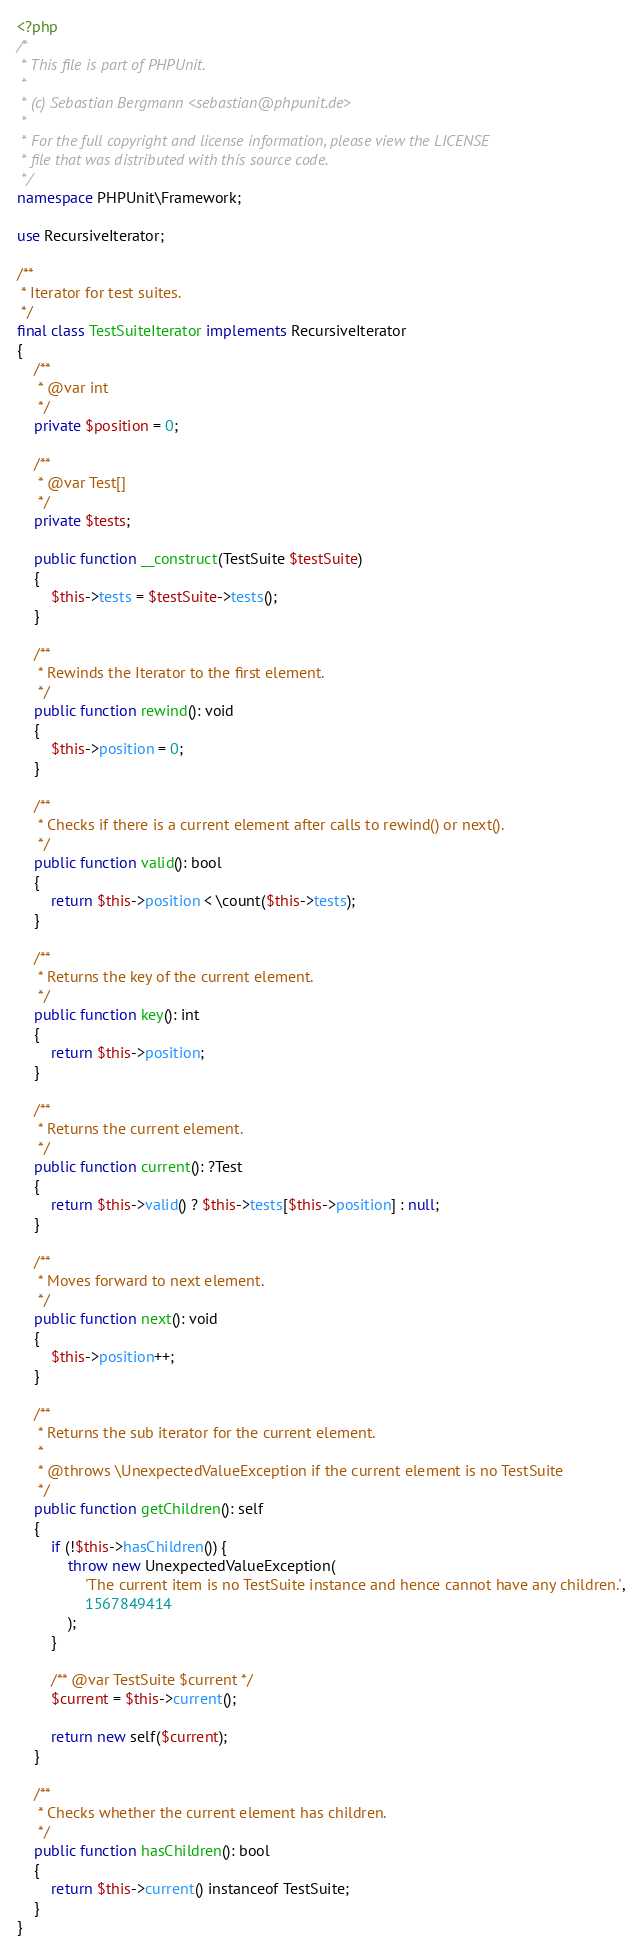<code> <loc_0><loc_0><loc_500><loc_500><_PHP_><?php
/*
 * This file is part of PHPUnit.
 *
 * (c) Sebastian Bergmann <sebastian@phpunit.de>
 *
 * For the full copyright and license information, please view the LICENSE
 * file that was distributed with this source code.
 */
namespace PHPUnit\Framework;

use RecursiveIterator;

/**
 * Iterator for test suites.
 */
final class TestSuiteIterator implements RecursiveIterator
{
    /**
     * @var int
     */
    private $position = 0;

    /**
     * @var Test[]
     */
    private $tests;

    public function __construct(TestSuite $testSuite)
    {
        $this->tests = $testSuite->tests();
    }

    /**
     * Rewinds the Iterator to the first element.
     */
    public function rewind(): void
    {
        $this->position = 0;
    }

    /**
     * Checks if there is a current element after calls to rewind() or next().
     */
    public function valid(): bool
    {
        return $this->position < \count($this->tests);
    }

    /**
     * Returns the key of the current element.
     */
    public function key(): int
    {
        return $this->position;
    }

    /**
     * Returns the current element.
     */
    public function current(): ?Test
    {
        return $this->valid() ? $this->tests[$this->position] : null;
    }

    /**
     * Moves forward to next element.
     */
    public function next(): void
    {
        $this->position++;
    }

    /**
     * Returns the sub iterator for the current element.
     *
     * @throws \UnexpectedValueException if the current element is no TestSuite
     */
    public function getChildren(): self
    {
        if (!$this->hasChildren()) {
            throw new UnexpectedValueException(
                'The current item is no TestSuite instance and hence cannot have any children.',
                1567849414
            );
        }

        /** @var TestSuite $current */
        $current = $this->current();

        return new self($current);
    }

    /**
     * Checks whether the current element has children.
     */
    public function hasChildren(): bool
    {
        return $this->current() instanceof TestSuite;
    }
}
</code> 